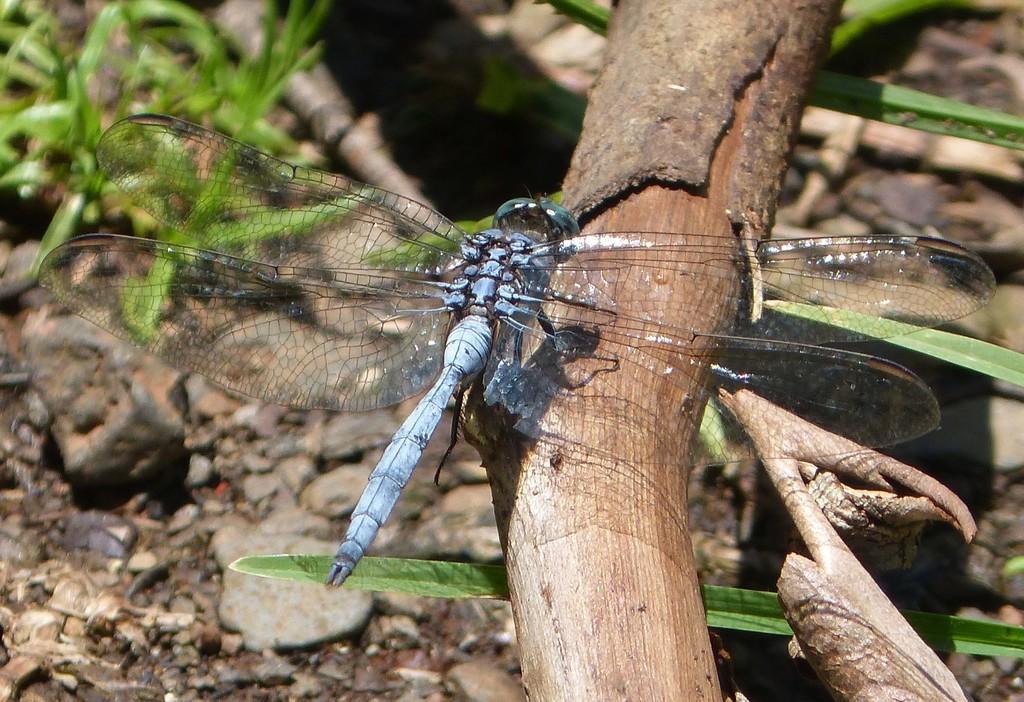Can you describe this image briefly? In the image there is a dragon fly standing on stick, below the land is covered with stones and grass. 